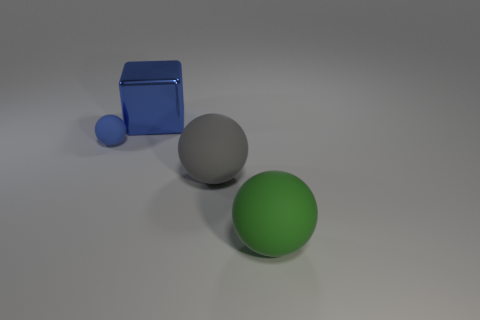Add 2 tiny green metal spheres. How many objects exist? 6 Subtract all cubes. How many objects are left? 3 Add 2 tiny metallic objects. How many tiny metallic objects exist? 2 Subtract 0 purple blocks. How many objects are left? 4 Subtract all gray things. Subtract all large gray rubber things. How many objects are left? 2 Add 1 green spheres. How many green spheres are left? 2 